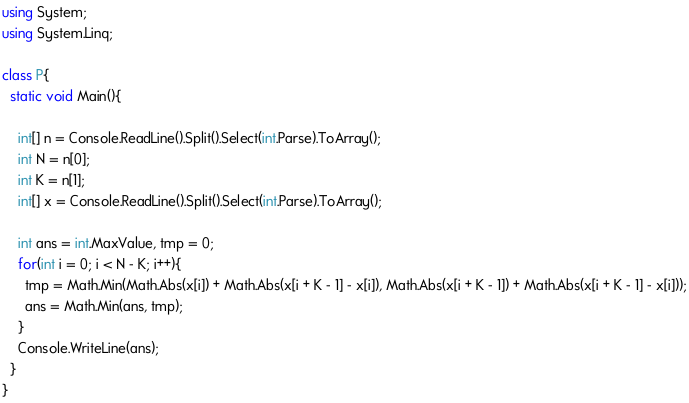Convert code to text. <code><loc_0><loc_0><loc_500><loc_500><_C#_>using System;
using System.Linq;

class P{
  static void Main(){
    
    int[] n = Console.ReadLine().Split().Select(int.Parse).ToArray();
    int N = n[0];
    int K = n[1];
    int[] x = Console.ReadLine().Split().Select(int.Parse).ToArray();
    
    int ans = int.MaxValue, tmp = 0;
    for(int i = 0; i < N - K; i++){
      tmp = Math.Min(Math.Abs(x[i]) + Math.Abs(x[i + K - 1] - x[i]), Math.Abs(x[i + K - 1]) + Math.Abs(x[i + K - 1] - x[i]));
      ans = Math.Min(ans, tmp);
    }
    Console.WriteLine(ans);
  }
}</code> 